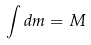Convert formula to latex. <formula><loc_0><loc_0><loc_500><loc_500>\int d m = M</formula> 